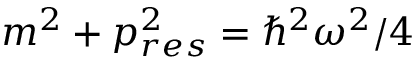<formula> <loc_0><loc_0><loc_500><loc_500>m ^ { 2 } + p _ { r e s } ^ { 2 } = \hbar { ^ } { 2 } \omega ^ { 2 } / 4</formula> 